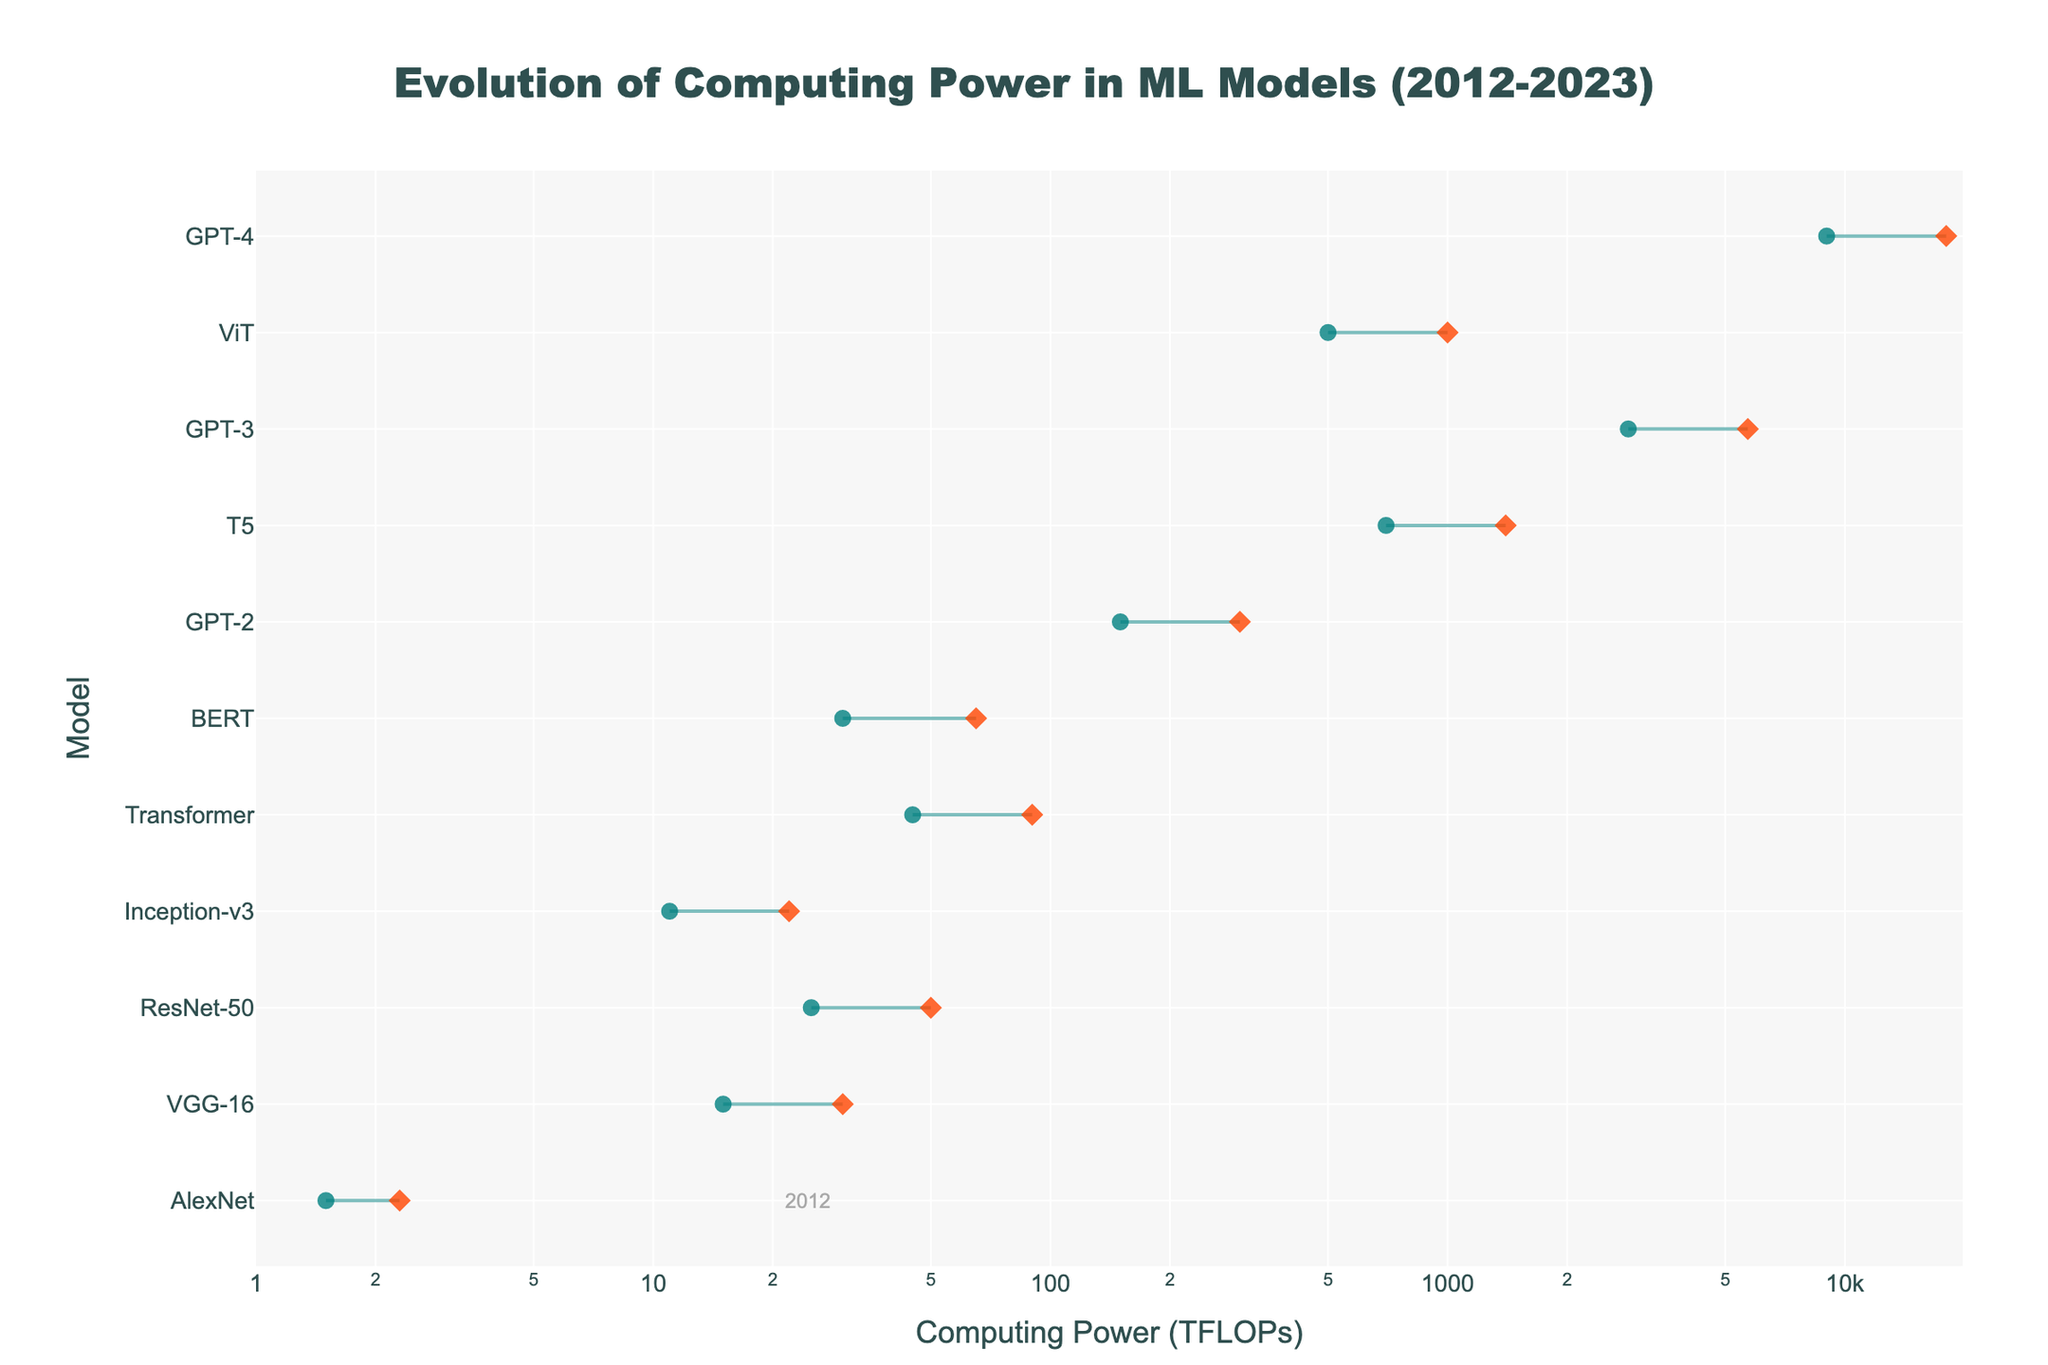What's the title of the plot? The title of the plot is usually placed at the top of the graph. In this case, the title is "Evolution of Computing Power in ML Models (2012-2023)" as stated in the code.
Answer: Evolution of Computing Power in ML Models (2012-2023) What is the x-axis label? The x-axis label is used to indicate what is being measured along the horizontal axis. According to the code, it is "Computing Power (TFLOPs)".
Answer: Computing Power (TFLOPs) Which model introduced in 2020 has the higher maximum computing power requirement? The plot shows two models introduced in 2020: T5 and GPT-3. By comparing the maximum computing power values, GPT-3 has a higher maximum computing power of 5700 TFLOPs compared to T5's 1400 TFLOPs.
Answer: GPT-3 Which model has the smallest computing power requirement? To find the model with the smallest computing power requirement, we look at the minimum computing power values. AlexNet introduced in 2012 has the smallest minimum computing power requirement of 1.5 TFLOPs.
Answer: AlexNet How many models have their maximum computing power requirement greater than or equal to 1000 TFLOPs? By examining the maximum computing power values, T5, GPT-3, ViT, and GPT-4 have a maximum computing power requirement of 1000 TFLOPs or more. So, there are 4 models in total.
Answer: 4 How much did the maximum computing power requirement for GPT models increase from GPT-2 to GPT-4? To find this, subtract the maximum computing power of GPT-2 (300 TFLOPs) from GPT-4 (18000 TFLOPs). This is 18000 - 300 = 17700 TFLOPs.
Answer: 17700 TFLOPs What is the average maximum computing power requirement for models introduced between 2017 and 2020 inclusive? Models introduced between 2017 and 2020 are Transformer, BERT, GPT-2, T5, and GPT-3 with maximum computing powers of 90, 65, 300, 1400, and 5700 TFLOPs respectively. The average is (90 + 65 + 300 + 1400 + 5700) / 5 = 1551 TFLOPs.
Answer: 1551 TFLOPs Which model shows the largest gap between its minimum and maximum computing power requirements? To determine the largest gap, subtract the minimum computing power from the maximum for each model. GPT-4 has the largest gap: 18000 - 9000 = 9000 TFLOPs.
Answer: GPT-4 